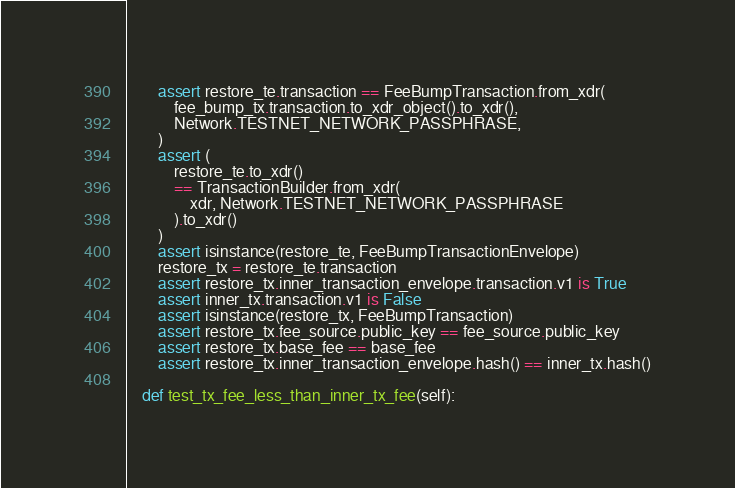Convert code to text. <code><loc_0><loc_0><loc_500><loc_500><_Python_>        assert restore_te.transaction == FeeBumpTransaction.from_xdr(
            fee_bump_tx.transaction.to_xdr_object().to_xdr(),
            Network.TESTNET_NETWORK_PASSPHRASE,
        )
        assert (
            restore_te.to_xdr()
            == TransactionBuilder.from_xdr(
                xdr, Network.TESTNET_NETWORK_PASSPHRASE
            ).to_xdr()
        )
        assert isinstance(restore_te, FeeBumpTransactionEnvelope)
        restore_tx = restore_te.transaction
        assert restore_tx.inner_transaction_envelope.transaction.v1 is True
        assert inner_tx.transaction.v1 is False
        assert isinstance(restore_tx, FeeBumpTransaction)
        assert restore_tx.fee_source.public_key == fee_source.public_key
        assert restore_tx.base_fee == base_fee
        assert restore_tx.inner_transaction_envelope.hash() == inner_tx.hash()

    def test_tx_fee_less_than_inner_tx_fee(self):</code> 